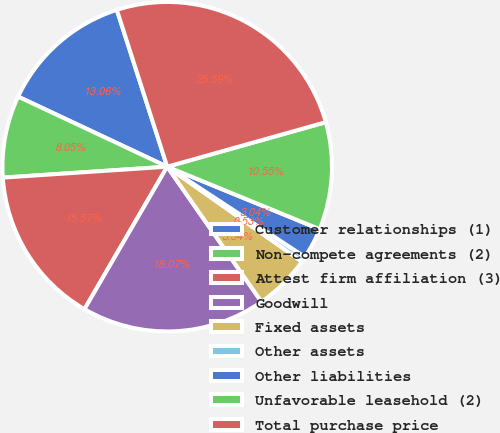Convert chart to OTSL. <chart><loc_0><loc_0><loc_500><loc_500><pie_chart><fcel>Customer relationships (1)<fcel>Non-compete agreements (2)<fcel>Attest firm affiliation (3)<fcel>Goodwill<fcel>Fixed assets<fcel>Other assets<fcel>Other liabilities<fcel>Unfavorable leasehold (2)<fcel>Total purchase price<nl><fcel>13.06%<fcel>8.05%<fcel>15.57%<fcel>18.07%<fcel>5.54%<fcel>0.53%<fcel>3.04%<fcel>10.55%<fcel>25.59%<nl></chart> 